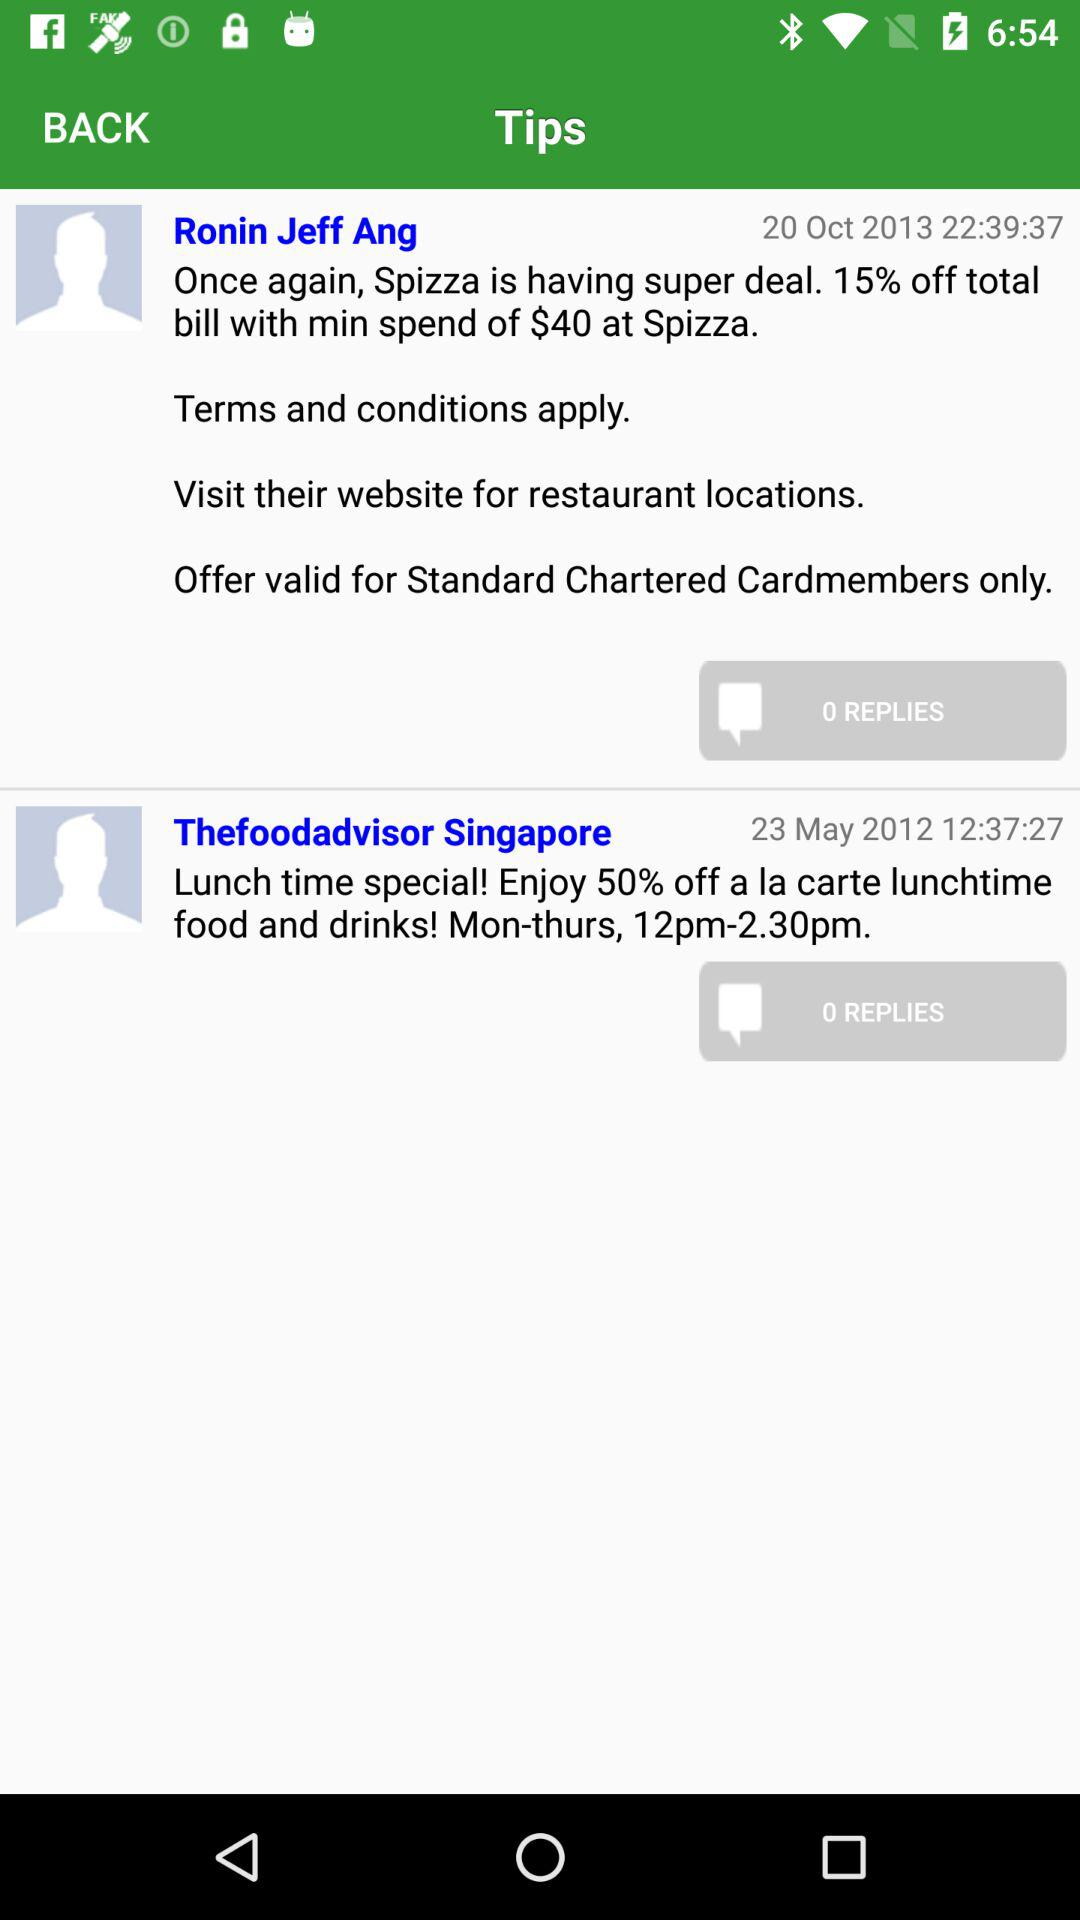How many replies are there for Ronin Jeff Ang? There are 0 replies. 